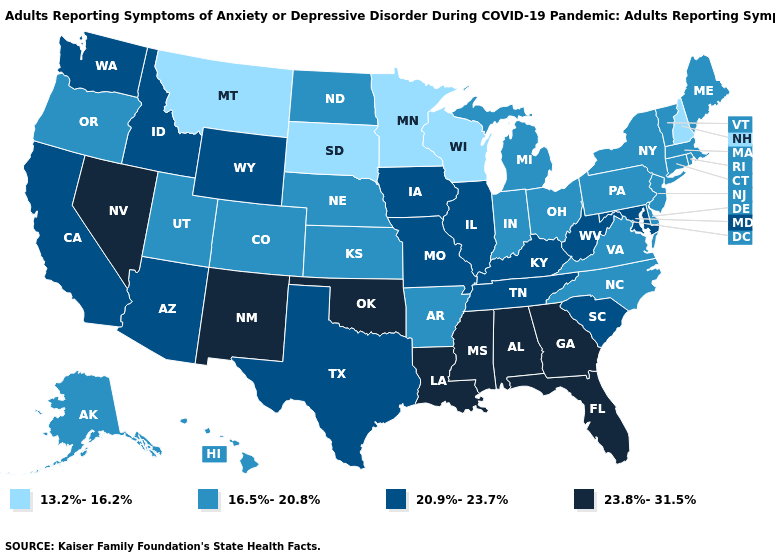Among the states that border Arizona , which have the lowest value?
Short answer required. Colorado, Utah. Does the map have missing data?
Give a very brief answer. No. What is the value of Michigan?
Concise answer only. 16.5%-20.8%. What is the value of Ohio?
Give a very brief answer. 16.5%-20.8%. Does Utah have the highest value in the USA?
Answer briefly. No. What is the value of Illinois?
Short answer required. 20.9%-23.7%. Is the legend a continuous bar?
Concise answer only. No. Does New Mexico have a higher value than Alaska?
Write a very short answer. Yes. What is the highest value in the MidWest ?
Be succinct. 20.9%-23.7%. Among the states that border South Dakota , does Minnesota have the highest value?
Be succinct. No. Which states have the lowest value in the MidWest?
Be succinct. Minnesota, South Dakota, Wisconsin. Does the map have missing data?
Short answer required. No. What is the value of Texas?
Be succinct. 20.9%-23.7%. Does Michigan have the lowest value in the MidWest?
Give a very brief answer. No. 